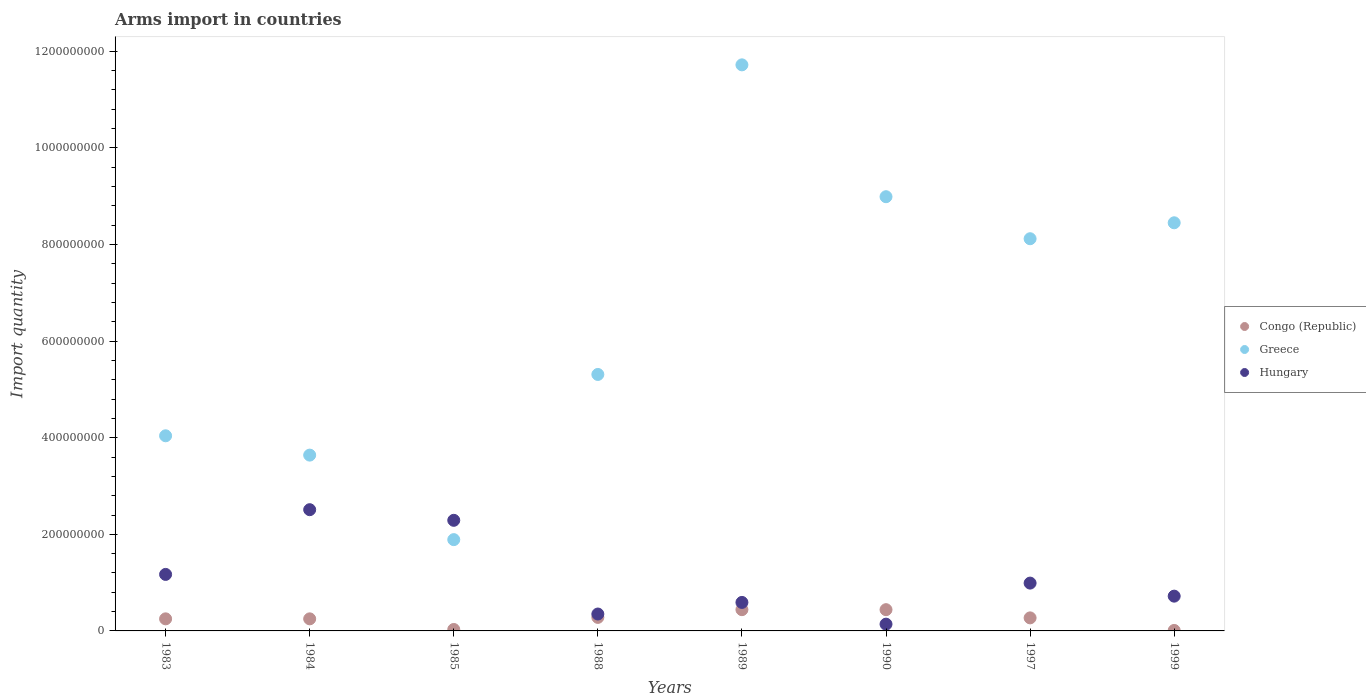Is the number of dotlines equal to the number of legend labels?
Offer a terse response. Yes. What is the total arms import in Greece in 1988?
Your response must be concise. 5.31e+08. Across all years, what is the maximum total arms import in Hungary?
Make the answer very short. 2.51e+08. Across all years, what is the minimum total arms import in Greece?
Your response must be concise. 1.89e+08. In which year was the total arms import in Hungary maximum?
Give a very brief answer. 1984. What is the total total arms import in Greece in the graph?
Your response must be concise. 5.22e+09. What is the difference between the total arms import in Congo (Republic) in 1990 and that in 1997?
Your answer should be very brief. 1.70e+07. What is the difference between the total arms import in Hungary in 1985 and the total arms import in Greece in 1989?
Make the answer very short. -9.43e+08. What is the average total arms import in Hungary per year?
Your answer should be compact. 1.10e+08. In the year 1984, what is the difference between the total arms import in Congo (Republic) and total arms import in Hungary?
Provide a short and direct response. -2.26e+08. In how many years, is the total arms import in Hungary greater than 80000000?
Give a very brief answer. 4. What is the ratio of the total arms import in Hungary in 1984 to that in 1997?
Provide a succinct answer. 2.54. Is the difference between the total arms import in Congo (Republic) in 1984 and 1999 greater than the difference between the total arms import in Hungary in 1984 and 1999?
Your answer should be compact. No. What is the difference between the highest and the lowest total arms import in Greece?
Provide a short and direct response. 9.83e+08. In how many years, is the total arms import in Congo (Republic) greater than the average total arms import in Congo (Republic) taken over all years?
Offer a very short reply. 6. Is the total arms import in Hungary strictly greater than the total arms import in Greece over the years?
Keep it short and to the point. No. Are the values on the major ticks of Y-axis written in scientific E-notation?
Your answer should be compact. No. Does the graph contain any zero values?
Keep it short and to the point. No. Does the graph contain grids?
Provide a succinct answer. No. How many legend labels are there?
Make the answer very short. 3. How are the legend labels stacked?
Make the answer very short. Vertical. What is the title of the graph?
Offer a very short reply. Arms import in countries. Does "Togo" appear as one of the legend labels in the graph?
Provide a succinct answer. No. What is the label or title of the X-axis?
Give a very brief answer. Years. What is the label or title of the Y-axis?
Provide a succinct answer. Import quantity. What is the Import quantity of Congo (Republic) in 1983?
Make the answer very short. 2.50e+07. What is the Import quantity in Greece in 1983?
Provide a succinct answer. 4.04e+08. What is the Import quantity of Hungary in 1983?
Give a very brief answer. 1.17e+08. What is the Import quantity of Congo (Republic) in 1984?
Keep it short and to the point. 2.50e+07. What is the Import quantity in Greece in 1984?
Provide a short and direct response. 3.64e+08. What is the Import quantity in Hungary in 1984?
Your answer should be very brief. 2.51e+08. What is the Import quantity in Congo (Republic) in 1985?
Provide a short and direct response. 3.00e+06. What is the Import quantity of Greece in 1985?
Offer a terse response. 1.89e+08. What is the Import quantity of Hungary in 1985?
Offer a terse response. 2.29e+08. What is the Import quantity in Congo (Republic) in 1988?
Make the answer very short. 2.80e+07. What is the Import quantity of Greece in 1988?
Make the answer very short. 5.31e+08. What is the Import quantity in Hungary in 1988?
Your answer should be very brief. 3.50e+07. What is the Import quantity of Congo (Republic) in 1989?
Provide a succinct answer. 4.40e+07. What is the Import quantity of Greece in 1989?
Your answer should be very brief. 1.17e+09. What is the Import quantity of Hungary in 1989?
Your answer should be very brief. 5.90e+07. What is the Import quantity of Congo (Republic) in 1990?
Offer a terse response. 4.40e+07. What is the Import quantity of Greece in 1990?
Offer a terse response. 8.99e+08. What is the Import quantity in Hungary in 1990?
Make the answer very short. 1.40e+07. What is the Import quantity in Congo (Republic) in 1997?
Keep it short and to the point. 2.70e+07. What is the Import quantity of Greece in 1997?
Your answer should be compact. 8.12e+08. What is the Import quantity in Hungary in 1997?
Keep it short and to the point. 9.90e+07. What is the Import quantity in Greece in 1999?
Provide a succinct answer. 8.45e+08. What is the Import quantity in Hungary in 1999?
Offer a terse response. 7.20e+07. Across all years, what is the maximum Import quantity of Congo (Republic)?
Offer a very short reply. 4.40e+07. Across all years, what is the maximum Import quantity in Greece?
Ensure brevity in your answer.  1.17e+09. Across all years, what is the maximum Import quantity of Hungary?
Ensure brevity in your answer.  2.51e+08. Across all years, what is the minimum Import quantity in Congo (Republic)?
Ensure brevity in your answer.  1.00e+06. Across all years, what is the minimum Import quantity of Greece?
Offer a terse response. 1.89e+08. Across all years, what is the minimum Import quantity in Hungary?
Provide a short and direct response. 1.40e+07. What is the total Import quantity in Congo (Republic) in the graph?
Offer a terse response. 1.97e+08. What is the total Import quantity of Greece in the graph?
Offer a very short reply. 5.22e+09. What is the total Import quantity of Hungary in the graph?
Ensure brevity in your answer.  8.76e+08. What is the difference between the Import quantity of Congo (Republic) in 1983 and that in 1984?
Offer a terse response. 0. What is the difference between the Import quantity of Greece in 1983 and that in 1984?
Give a very brief answer. 4.00e+07. What is the difference between the Import quantity of Hungary in 1983 and that in 1984?
Provide a short and direct response. -1.34e+08. What is the difference between the Import quantity of Congo (Republic) in 1983 and that in 1985?
Offer a very short reply. 2.20e+07. What is the difference between the Import quantity of Greece in 1983 and that in 1985?
Offer a very short reply. 2.15e+08. What is the difference between the Import quantity of Hungary in 1983 and that in 1985?
Give a very brief answer. -1.12e+08. What is the difference between the Import quantity in Greece in 1983 and that in 1988?
Your response must be concise. -1.27e+08. What is the difference between the Import quantity of Hungary in 1983 and that in 1988?
Give a very brief answer. 8.20e+07. What is the difference between the Import quantity of Congo (Republic) in 1983 and that in 1989?
Offer a terse response. -1.90e+07. What is the difference between the Import quantity of Greece in 1983 and that in 1989?
Provide a short and direct response. -7.68e+08. What is the difference between the Import quantity in Hungary in 1983 and that in 1989?
Offer a very short reply. 5.80e+07. What is the difference between the Import quantity of Congo (Republic) in 1983 and that in 1990?
Give a very brief answer. -1.90e+07. What is the difference between the Import quantity of Greece in 1983 and that in 1990?
Provide a short and direct response. -4.95e+08. What is the difference between the Import quantity of Hungary in 1983 and that in 1990?
Make the answer very short. 1.03e+08. What is the difference between the Import quantity of Greece in 1983 and that in 1997?
Offer a terse response. -4.08e+08. What is the difference between the Import quantity of Hungary in 1983 and that in 1997?
Your response must be concise. 1.80e+07. What is the difference between the Import quantity in Congo (Republic) in 1983 and that in 1999?
Offer a very short reply. 2.40e+07. What is the difference between the Import quantity in Greece in 1983 and that in 1999?
Make the answer very short. -4.41e+08. What is the difference between the Import quantity of Hungary in 1983 and that in 1999?
Provide a succinct answer. 4.50e+07. What is the difference between the Import quantity of Congo (Republic) in 1984 and that in 1985?
Your answer should be very brief. 2.20e+07. What is the difference between the Import quantity in Greece in 1984 and that in 1985?
Your response must be concise. 1.75e+08. What is the difference between the Import quantity in Hungary in 1984 and that in 1985?
Offer a very short reply. 2.20e+07. What is the difference between the Import quantity in Congo (Republic) in 1984 and that in 1988?
Keep it short and to the point. -3.00e+06. What is the difference between the Import quantity in Greece in 1984 and that in 1988?
Make the answer very short. -1.67e+08. What is the difference between the Import quantity in Hungary in 1984 and that in 1988?
Offer a very short reply. 2.16e+08. What is the difference between the Import quantity in Congo (Republic) in 1984 and that in 1989?
Offer a very short reply. -1.90e+07. What is the difference between the Import quantity in Greece in 1984 and that in 1989?
Make the answer very short. -8.08e+08. What is the difference between the Import quantity in Hungary in 1984 and that in 1989?
Your answer should be very brief. 1.92e+08. What is the difference between the Import quantity of Congo (Republic) in 1984 and that in 1990?
Offer a terse response. -1.90e+07. What is the difference between the Import quantity in Greece in 1984 and that in 1990?
Provide a succinct answer. -5.35e+08. What is the difference between the Import quantity in Hungary in 1984 and that in 1990?
Your response must be concise. 2.37e+08. What is the difference between the Import quantity in Congo (Republic) in 1984 and that in 1997?
Your answer should be compact. -2.00e+06. What is the difference between the Import quantity of Greece in 1984 and that in 1997?
Make the answer very short. -4.48e+08. What is the difference between the Import quantity of Hungary in 1984 and that in 1997?
Your response must be concise. 1.52e+08. What is the difference between the Import quantity of Congo (Republic) in 1984 and that in 1999?
Provide a short and direct response. 2.40e+07. What is the difference between the Import quantity in Greece in 1984 and that in 1999?
Ensure brevity in your answer.  -4.81e+08. What is the difference between the Import quantity of Hungary in 1984 and that in 1999?
Offer a very short reply. 1.79e+08. What is the difference between the Import quantity in Congo (Republic) in 1985 and that in 1988?
Your response must be concise. -2.50e+07. What is the difference between the Import quantity in Greece in 1985 and that in 1988?
Offer a very short reply. -3.42e+08. What is the difference between the Import quantity of Hungary in 1985 and that in 1988?
Ensure brevity in your answer.  1.94e+08. What is the difference between the Import quantity in Congo (Republic) in 1985 and that in 1989?
Your answer should be very brief. -4.10e+07. What is the difference between the Import quantity of Greece in 1985 and that in 1989?
Provide a succinct answer. -9.83e+08. What is the difference between the Import quantity in Hungary in 1985 and that in 1989?
Offer a terse response. 1.70e+08. What is the difference between the Import quantity of Congo (Republic) in 1985 and that in 1990?
Give a very brief answer. -4.10e+07. What is the difference between the Import quantity in Greece in 1985 and that in 1990?
Keep it short and to the point. -7.10e+08. What is the difference between the Import quantity of Hungary in 1985 and that in 1990?
Provide a succinct answer. 2.15e+08. What is the difference between the Import quantity of Congo (Republic) in 1985 and that in 1997?
Your answer should be compact. -2.40e+07. What is the difference between the Import quantity of Greece in 1985 and that in 1997?
Provide a succinct answer. -6.23e+08. What is the difference between the Import quantity in Hungary in 1985 and that in 1997?
Keep it short and to the point. 1.30e+08. What is the difference between the Import quantity of Greece in 1985 and that in 1999?
Ensure brevity in your answer.  -6.56e+08. What is the difference between the Import quantity in Hungary in 1985 and that in 1999?
Your answer should be compact. 1.57e+08. What is the difference between the Import quantity in Congo (Republic) in 1988 and that in 1989?
Your answer should be compact. -1.60e+07. What is the difference between the Import quantity in Greece in 1988 and that in 1989?
Keep it short and to the point. -6.41e+08. What is the difference between the Import quantity of Hungary in 1988 and that in 1989?
Make the answer very short. -2.40e+07. What is the difference between the Import quantity in Congo (Republic) in 1988 and that in 1990?
Your answer should be very brief. -1.60e+07. What is the difference between the Import quantity of Greece in 1988 and that in 1990?
Offer a terse response. -3.68e+08. What is the difference between the Import quantity in Hungary in 1988 and that in 1990?
Provide a succinct answer. 2.10e+07. What is the difference between the Import quantity in Congo (Republic) in 1988 and that in 1997?
Provide a succinct answer. 1.00e+06. What is the difference between the Import quantity in Greece in 1988 and that in 1997?
Provide a short and direct response. -2.81e+08. What is the difference between the Import quantity of Hungary in 1988 and that in 1997?
Your response must be concise. -6.40e+07. What is the difference between the Import quantity in Congo (Republic) in 1988 and that in 1999?
Provide a short and direct response. 2.70e+07. What is the difference between the Import quantity in Greece in 1988 and that in 1999?
Give a very brief answer. -3.14e+08. What is the difference between the Import quantity in Hungary in 1988 and that in 1999?
Your response must be concise. -3.70e+07. What is the difference between the Import quantity in Greece in 1989 and that in 1990?
Your response must be concise. 2.73e+08. What is the difference between the Import quantity of Hungary in 1989 and that in 1990?
Offer a terse response. 4.50e+07. What is the difference between the Import quantity in Congo (Republic) in 1989 and that in 1997?
Your answer should be very brief. 1.70e+07. What is the difference between the Import quantity of Greece in 1989 and that in 1997?
Make the answer very short. 3.60e+08. What is the difference between the Import quantity of Hungary in 1989 and that in 1997?
Your answer should be compact. -4.00e+07. What is the difference between the Import quantity in Congo (Republic) in 1989 and that in 1999?
Your response must be concise. 4.30e+07. What is the difference between the Import quantity of Greece in 1989 and that in 1999?
Keep it short and to the point. 3.27e+08. What is the difference between the Import quantity of Hungary in 1989 and that in 1999?
Provide a short and direct response. -1.30e+07. What is the difference between the Import quantity in Congo (Republic) in 1990 and that in 1997?
Give a very brief answer. 1.70e+07. What is the difference between the Import quantity of Greece in 1990 and that in 1997?
Offer a terse response. 8.70e+07. What is the difference between the Import quantity in Hungary in 1990 and that in 1997?
Your answer should be very brief. -8.50e+07. What is the difference between the Import quantity in Congo (Republic) in 1990 and that in 1999?
Ensure brevity in your answer.  4.30e+07. What is the difference between the Import quantity of Greece in 1990 and that in 1999?
Your answer should be very brief. 5.40e+07. What is the difference between the Import quantity in Hungary in 1990 and that in 1999?
Offer a very short reply. -5.80e+07. What is the difference between the Import quantity in Congo (Republic) in 1997 and that in 1999?
Give a very brief answer. 2.60e+07. What is the difference between the Import quantity of Greece in 1997 and that in 1999?
Give a very brief answer. -3.30e+07. What is the difference between the Import quantity of Hungary in 1997 and that in 1999?
Give a very brief answer. 2.70e+07. What is the difference between the Import quantity of Congo (Republic) in 1983 and the Import quantity of Greece in 1984?
Give a very brief answer. -3.39e+08. What is the difference between the Import quantity in Congo (Republic) in 1983 and the Import quantity in Hungary in 1984?
Provide a short and direct response. -2.26e+08. What is the difference between the Import quantity in Greece in 1983 and the Import quantity in Hungary in 1984?
Your answer should be very brief. 1.53e+08. What is the difference between the Import quantity in Congo (Republic) in 1983 and the Import quantity in Greece in 1985?
Keep it short and to the point. -1.64e+08. What is the difference between the Import quantity in Congo (Republic) in 1983 and the Import quantity in Hungary in 1985?
Offer a very short reply. -2.04e+08. What is the difference between the Import quantity in Greece in 1983 and the Import quantity in Hungary in 1985?
Give a very brief answer. 1.75e+08. What is the difference between the Import quantity in Congo (Republic) in 1983 and the Import quantity in Greece in 1988?
Provide a short and direct response. -5.06e+08. What is the difference between the Import quantity in Congo (Republic) in 1983 and the Import quantity in Hungary in 1988?
Give a very brief answer. -1.00e+07. What is the difference between the Import quantity in Greece in 1983 and the Import quantity in Hungary in 1988?
Provide a succinct answer. 3.69e+08. What is the difference between the Import quantity in Congo (Republic) in 1983 and the Import quantity in Greece in 1989?
Make the answer very short. -1.15e+09. What is the difference between the Import quantity in Congo (Republic) in 1983 and the Import quantity in Hungary in 1989?
Provide a short and direct response. -3.40e+07. What is the difference between the Import quantity in Greece in 1983 and the Import quantity in Hungary in 1989?
Offer a terse response. 3.45e+08. What is the difference between the Import quantity of Congo (Republic) in 1983 and the Import quantity of Greece in 1990?
Make the answer very short. -8.74e+08. What is the difference between the Import quantity of Congo (Republic) in 1983 and the Import quantity of Hungary in 1990?
Ensure brevity in your answer.  1.10e+07. What is the difference between the Import quantity of Greece in 1983 and the Import quantity of Hungary in 1990?
Your answer should be very brief. 3.90e+08. What is the difference between the Import quantity in Congo (Republic) in 1983 and the Import quantity in Greece in 1997?
Offer a very short reply. -7.87e+08. What is the difference between the Import quantity of Congo (Republic) in 1983 and the Import quantity of Hungary in 1997?
Give a very brief answer. -7.40e+07. What is the difference between the Import quantity of Greece in 1983 and the Import quantity of Hungary in 1997?
Make the answer very short. 3.05e+08. What is the difference between the Import quantity in Congo (Republic) in 1983 and the Import quantity in Greece in 1999?
Offer a very short reply. -8.20e+08. What is the difference between the Import quantity of Congo (Republic) in 1983 and the Import quantity of Hungary in 1999?
Give a very brief answer. -4.70e+07. What is the difference between the Import quantity in Greece in 1983 and the Import quantity in Hungary in 1999?
Your answer should be very brief. 3.32e+08. What is the difference between the Import quantity of Congo (Republic) in 1984 and the Import quantity of Greece in 1985?
Give a very brief answer. -1.64e+08. What is the difference between the Import quantity of Congo (Republic) in 1984 and the Import quantity of Hungary in 1985?
Offer a terse response. -2.04e+08. What is the difference between the Import quantity in Greece in 1984 and the Import quantity in Hungary in 1985?
Your response must be concise. 1.35e+08. What is the difference between the Import quantity in Congo (Republic) in 1984 and the Import quantity in Greece in 1988?
Keep it short and to the point. -5.06e+08. What is the difference between the Import quantity of Congo (Republic) in 1984 and the Import quantity of Hungary in 1988?
Make the answer very short. -1.00e+07. What is the difference between the Import quantity in Greece in 1984 and the Import quantity in Hungary in 1988?
Offer a terse response. 3.29e+08. What is the difference between the Import quantity of Congo (Republic) in 1984 and the Import quantity of Greece in 1989?
Ensure brevity in your answer.  -1.15e+09. What is the difference between the Import quantity of Congo (Republic) in 1984 and the Import quantity of Hungary in 1989?
Offer a terse response. -3.40e+07. What is the difference between the Import quantity of Greece in 1984 and the Import quantity of Hungary in 1989?
Give a very brief answer. 3.05e+08. What is the difference between the Import quantity of Congo (Republic) in 1984 and the Import quantity of Greece in 1990?
Your answer should be compact. -8.74e+08. What is the difference between the Import quantity in Congo (Republic) in 1984 and the Import quantity in Hungary in 1990?
Provide a succinct answer. 1.10e+07. What is the difference between the Import quantity of Greece in 1984 and the Import quantity of Hungary in 1990?
Give a very brief answer. 3.50e+08. What is the difference between the Import quantity in Congo (Republic) in 1984 and the Import quantity in Greece in 1997?
Provide a short and direct response. -7.87e+08. What is the difference between the Import quantity in Congo (Republic) in 1984 and the Import quantity in Hungary in 1997?
Your answer should be very brief. -7.40e+07. What is the difference between the Import quantity in Greece in 1984 and the Import quantity in Hungary in 1997?
Offer a very short reply. 2.65e+08. What is the difference between the Import quantity in Congo (Republic) in 1984 and the Import quantity in Greece in 1999?
Ensure brevity in your answer.  -8.20e+08. What is the difference between the Import quantity of Congo (Republic) in 1984 and the Import quantity of Hungary in 1999?
Make the answer very short. -4.70e+07. What is the difference between the Import quantity of Greece in 1984 and the Import quantity of Hungary in 1999?
Provide a short and direct response. 2.92e+08. What is the difference between the Import quantity of Congo (Republic) in 1985 and the Import quantity of Greece in 1988?
Your answer should be compact. -5.28e+08. What is the difference between the Import quantity of Congo (Republic) in 1985 and the Import quantity of Hungary in 1988?
Your answer should be compact. -3.20e+07. What is the difference between the Import quantity in Greece in 1985 and the Import quantity in Hungary in 1988?
Ensure brevity in your answer.  1.54e+08. What is the difference between the Import quantity of Congo (Republic) in 1985 and the Import quantity of Greece in 1989?
Keep it short and to the point. -1.17e+09. What is the difference between the Import quantity of Congo (Republic) in 1985 and the Import quantity of Hungary in 1989?
Ensure brevity in your answer.  -5.60e+07. What is the difference between the Import quantity of Greece in 1985 and the Import quantity of Hungary in 1989?
Make the answer very short. 1.30e+08. What is the difference between the Import quantity of Congo (Republic) in 1985 and the Import quantity of Greece in 1990?
Your answer should be very brief. -8.96e+08. What is the difference between the Import quantity of Congo (Republic) in 1985 and the Import quantity of Hungary in 1990?
Provide a short and direct response. -1.10e+07. What is the difference between the Import quantity in Greece in 1985 and the Import quantity in Hungary in 1990?
Your answer should be compact. 1.75e+08. What is the difference between the Import quantity in Congo (Republic) in 1985 and the Import quantity in Greece in 1997?
Offer a terse response. -8.09e+08. What is the difference between the Import quantity of Congo (Republic) in 1985 and the Import quantity of Hungary in 1997?
Your response must be concise. -9.60e+07. What is the difference between the Import quantity of Greece in 1985 and the Import quantity of Hungary in 1997?
Make the answer very short. 9.00e+07. What is the difference between the Import quantity in Congo (Republic) in 1985 and the Import quantity in Greece in 1999?
Make the answer very short. -8.42e+08. What is the difference between the Import quantity in Congo (Republic) in 1985 and the Import quantity in Hungary in 1999?
Provide a succinct answer. -6.90e+07. What is the difference between the Import quantity of Greece in 1985 and the Import quantity of Hungary in 1999?
Make the answer very short. 1.17e+08. What is the difference between the Import quantity of Congo (Republic) in 1988 and the Import quantity of Greece in 1989?
Your answer should be very brief. -1.14e+09. What is the difference between the Import quantity in Congo (Republic) in 1988 and the Import quantity in Hungary in 1989?
Ensure brevity in your answer.  -3.10e+07. What is the difference between the Import quantity in Greece in 1988 and the Import quantity in Hungary in 1989?
Give a very brief answer. 4.72e+08. What is the difference between the Import quantity in Congo (Republic) in 1988 and the Import quantity in Greece in 1990?
Provide a short and direct response. -8.71e+08. What is the difference between the Import quantity of Congo (Republic) in 1988 and the Import quantity of Hungary in 1990?
Your response must be concise. 1.40e+07. What is the difference between the Import quantity of Greece in 1988 and the Import quantity of Hungary in 1990?
Your answer should be very brief. 5.17e+08. What is the difference between the Import quantity of Congo (Republic) in 1988 and the Import quantity of Greece in 1997?
Your answer should be very brief. -7.84e+08. What is the difference between the Import quantity of Congo (Republic) in 1988 and the Import quantity of Hungary in 1997?
Make the answer very short. -7.10e+07. What is the difference between the Import quantity in Greece in 1988 and the Import quantity in Hungary in 1997?
Offer a terse response. 4.32e+08. What is the difference between the Import quantity of Congo (Republic) in 1988 and the Import quantity of Greece in 1999?
Your response must be concise. -8.17e+08. What is the difference between the Import quantity in Congo (Republic) in 1988 and the Import quantity in Hungary in 1999?
Your answer should be very brief. -4.40e+07. What is the difference between the Import quantity in Greece in 1988 and the Import quantity in Hungary in 1999?
Provide a short and direct response. 4.59e+08. What is the difference between the Import quantity in Congo (Republic) in 1989 and the Import quantity in Greece in 1990?
Provide a succinct answer. -8.55e+08. What is the difference between the Import quantity in Congo (Republic) in 1989 and the Import quantity in Hungary in 1990?
Your response must be concise. 3.00e+07. What is the difference between the Import quantity of Greece in 1989 and the Import quantity of Hungary in 1990?
Offer a very short reply. 1.16e+09. What is the difference between the Import quantity of Congo (Republic) in 1989 and the Import quantity of Greece in 1997?
Provide a succinct answer. -7.68e+08. What is the difference between the Import quantity of Congo (Republic) in 1989 and the Import quantity of Hungary in 1997?
Keep it short and to the point. -5.50e+07. What is the difference between the Import quantity in Greece in 1989 and the Import quantity in Hungary in 1997?
Ensure brevity in your answer.  1.07e+09. What is the difference between the Import quantity of Congo (Republic) in 1989 and the Import quantity of Greece in 1999?
Keep it short and to the point. -8.01e+08. What is the difference between the Import quantity of Congo (Republic) in 1989 and the Import quantity of Hungary in 1999?
Your answer should be very brief. -2.80e+07. What is the difference between the Import quantity in Greece in 1989 and the Import quantity in Hungary in 1999?
Your response must be concise. 1.10e+09. What is the difference between the Import quantity in Congo (Republic) in 1990 and the Import quantity in Greece in 1997?
Your response must be concise. -7.68e+08. What is the difference between the Import quantity of Congo (Republic) in 1990 and the Import quantity of Hungary in 1997?
Ensure brevity in your answer.  -5.50e+07. What is the difference between the Import quantity in Greece in 1990 and the Import quantity in Hungary in 1997?
Offer a very short reply. 8.00e+08. What is the difference between the Import quantity of Congo (Republic) in 1990 and the Import quantity of Greece in 1999?
Provide a short and direct response. -8.01e+08. What is the difference between the Import quantity of Congo (Republic) in 1990 and the Import quantity of Hungary in 1999?
Offer a very short reply. -2.80e+07. What is the difference between the Import quantity of Greece in 1990 and the Import quantity of Hungary in 1999?
Give a very brief answer. 8.27e+08. What is the difference between the Import quantity of Congo (Republic) in 1997 and the Import quantity of Greece in 1999?
Your response must be concise. -8.18e+08. What is the difference between the Import quantity of Congo (Republic) in 1997 and the Import quantity of Hungary in 1999?
Provide a succinct answer. -4.50e+07. What is the difference between the Import quantity of Greece in 1997 and the Import quantity of Hungary in 1999?
Provide a short and direct response. 7.40e+08. What is the average Import quantity of Congo (Republic) per year?
Your answer should be very brief. 2.46e+07. What is the average Import quantity in Greece per year?
Provide a short and direct response. 6.52e+08. What is the average Import quantity in Hungary per year?
Give a very brief answer. 1.10e+08. In the year 1983, what is the difference between the Import quantity in Congo (Republic) and Import quantity in Greece?
Provide a succinct answer. -3.79e+08. In the year 1983, what is the difference between the Import quantity of Congo (Republic) and Import quantity of Hungary?
Give a very brief answer. -9.20e+07. In the year 1983, what is the difference between the Import quantity in Greece and Import quantity in Hungary?
Provide a succinct answer. 2.87e+08. In the year 1984, what is the difference between the Import quantity in Congo (Republic) and Import quantity in Greece?
Offer a terse response. -3.39e+08. In the year 1984, what is the difference between the Import quantity in Congo (Republic) and Import quantity in Hungary?
Your answer should be very brief. -2.26e+08. In the year 1984, what is the difference between the Import quantity of Greece and Import quantity of Hungary?
Offer a terse response. 1.13e+08. In the year 1985, what is the difference between the Import quantity of Congo (Republic) and Import quantity of Greece?
Keep it short and to the point. -1.86e+08. In the year 1985, what is the difference between the Import quantity in Congo (Republic) and Import quantity in Hungary?
Offer a terse response. -2.26e+08. In the year 1985, what is the difference between the Import quantity of Greece and Import quantity of Hungary?
Offer a terse response. -4.00e+07. In the year 1988, what is the difference between the Import quantity of Congo (Republic) and Import quantity of Greece?
Offer a terse response. -5.03e+08. In the year 1988, what is the difference between the Import quantity in Congo (Republic) and Import quantity in Hungary?
Provide a short and direct response. -7.00e+06. In the year 1988, what is the difference between the Import quantity in Greece and Import quantity in Hungary?
Your answer should be very brief. 4.96e+08. In the year 1989, what is the difference between the Import quantity of Congo (Republic) and Import quantity of Greece?
Your answer should be compact. -1.13e+09. In the year 1989, what is the difference between the Import quantity in Congo (Republic) and Import quantity in Hungary?
Make the answer very short. -1.50e+07. In the year 1989, what is the difference between the Import quantity of Greece and Import quantity of Hungary?
Your answer should be compact. 1.11e+09. In the year 1990, what is the difference between the Import quantity of Congo (Republic) and Import quantity of Greece?
Keep it short and to the point. -8.55e+08. In the year 1990, what is the difference between the Import quantity of Congo (Republic) and Import quantity of Hungary?
Your response must be concise. 3.00e+07. In the year 1990, what is the difference between the Import quantity in Greece and Import quantity in Hungary?
Offer a terse response. 8.85e+08. In the year 1997, what is the difference between the Import quantity in Congo (Republic) and Import quantity in Greece?
Provide a succinct answer. -7.85e+08. In the year 1997, what is the difference between the Import quantity of Congo (Republic) and Import quantity of Hungary?
Your answer should be very brief. -7.20e+07. In the year 1997, what is the difference between the Import quantity in Greece and Import quantity in Hungary?
Give a very brief answer. 7.13e+08. In the year 1999, what is the difference between the Import quantity of Congo (Republic) and Import quantity of Greece?
Ensure brevity in your answer.  -8.44e+08. In the year 1999, what is the difference between the Import quantity in Congo (Republic) and Import quantity in Hungary?
Offer a very short reply. -7.10e+07. In the year 1999, what is the difference between the Import quantity in Greece and Import quantity in Hungary?
Provide a short and direct response. 7.73e+08. What is the ratio of the Import quantity in Congo (Republic) in 1983 to that in 1984?
Make the answer very short. 1. What is the ratio of the Import quantity in Greece in 1983 to that in 1984?
Your answer should be very brief. 1.11. What is the ratio of the Import quantity in Hungary in 1983 to that in 1984?
Provide a succinct answer. 0.47. What is the ratio of the Import quantity of Congo (Republic) in 1983 to that in 1985?
Give a very brief answer. 8.33. What is the ratio of the Import quantity in Greece in 1983 to that in 1985?
Give a very brief answer. 2.14. What is the ratio of the Import quantity in Hungary in 1983 to that in 1985?
Your answer should be very brief. 0.51. What is the ratio of the Import quantity of Congo (Republic) in 1983 to that in 1988?
Your answer should be very brief. 0.89. What is the ratio of the Import quantity of Greece in 1983 to that in 1988?
Give a very brief answer. 0.76. What is the ratio of the Import quantity in Hungary in 1983 to that in 1988?
Offer a very short reply. 3.34. What is the ratio of the Import quantity of Congo (Republic) in 1983 to that in 1989?
Offer a very short reply. 0.57. What is the ratio of the Import quantity in Greece in 1983 to that in 1989?
Make the answer very short. 0.34. What is the ratio of the Import quantity in Hungary in 1983 to that in 1989?
Your response must be concise. 1.98. What is the ratio of the Import quantity of Congo (Republic) in 1983 to that in 1990?
Make the answer very short. 0.57. What is the ratio of the Import quantity of Greece in 1983 to that in 1990?
Provide a short and direct response. 0.45. What is the ratio of the Import quantity in Hungary in 1983 to that in 1990?
Provide a short and direct response. 8.36. What is the ratio of the Import quantity of Congo (Republic) in 1983 to that in 1997?
Your answer should be compact. 0.93. What is the ratio of the Import quantity of Greece in 1983 to that in 1997?
Ensure brevity in your answer.  0.5. What is the ratio of the Import quantity of Hungary in 1983 to that in 1997?
Offer a very short reply. 1.18. What is the ratio of the Import quantity of Greece in 1983 to that in 1999?
Keep it short and to the point. 0.48. What is the ratio of the Import quantity of Hungary in 1983 to that in 1999?
Give a very brief answer. 1.62. What is the ratio of the Import quantity in Congo (Republic) in 1984 to that in 1985?
Your answer should be compact. 8.33. What is the ratio of the Import quantity in Greece in 1984 to that in 1985?
Keep it short and to the point. 1.93. What is the ratio of the Import quantity of Hungary in 1984 to that in 1985?
Give a very brief answer. 1.1. What is the ratio of the Import quantity of Congo (Republic) in 1984 to that in 1988?
Provide a short and direct response. 0.89. What is the ratio of the Import quantity of Greece in 1984 to that in 1988?
Your answer should be compact. 0.69. What is the ratio of the Import quantity in Hungary in 1984 to that in 1988?
Your answer should be compact. 7.17. What is the ratio of the Import quantity in Congo (Republic) in 1984 to that in 1989?
Your response must be concise. 0.57. What is the ratio of the Import quantity in Greece in 1984 to that in 1989?
Provide a short and direct response. 0.31. What is the ratio of the Import quantity in Hungary in 1984 to that in 1989?
Your answer should be compact. 4.25. What is the ratio of the Import quantity in Congo (Republic) in 1984 to that in 1990?
Make the answer very short. 0.57. What is the ratio of the Import quantity of Greece in 1984 to that in 1990?
Offer a very short reply. 0.4. What is the ratio of the Import quantity of Hungary in 1984 to that in 1990?
Ensure brevity in your answer.  17.93. What is the ratio of the Import quantity of Congo (Republic) in 1984 to that in 1997?
Keep it short and to the point. 0.93. What is the ratio of the Import quantity in Greece in 1984 to that in 1997?
Provide a short and direct response. 0.45. What is the ratio of the Import quantity in Hungary in 1984 to that in 1997?
Your answer should be very brief. 2.54. What is the ratio of the Import quantity in Greece in 1984 to that in 1999?
Provide a succinct answer. 0.43. What is the ratio of the Import quantity in Hungary in 1984 to that in 1999?
Your answer should be compact. 3.49. What is the ratio of the Import quantity of Congo (Republic) in 1985 to that in 1988?
Keep it short and to the point. 0.11. What is the ratio of the Import quantity of Greece in 1985 to that in 1988?
Provide a succinct answer. 0.36. What is the ratio of the Import quantity in Hungary in 1985 to that in 1988?
Your response must be concise. 6.54. What is the ratio of the Import quantity of Congo (Republic) in 1985 to that in 1989?
Offer a terse response. 0.07. What is the ratio of the Import quantity in Greece in 1985 to that in 1989?
Offer a very short reply. 0.16. What is the ratio of the Import quantity of Hungary in 1985 to that in 1989?
Your answer should be very brief. 3.88. What is the ratio of the Import quantity of Congo (Republic) in 1985 to that in 1990?
Offer a terse response. 0.07. What is the ratio of the Import quantity in Greece in 1985 to that in 1990?
Provide a succinct answer. 0.21. What is the ratio of the Import quantity of Hungary in 1985 to that in 1990?
Your answer should be compact. 16.36. What is the ratio of the Import quantity in Congo (Republic) in 1985 to that in 1997?
Your answer should be compact. 0.11. What is the ratio of the Import quantity in Greece in 1985 to that in 1997?
Your answer should be very brief. 0.23. What is the ratio of the Import quantity of Hungary in 1985 to that in 1997?
Offer a very short reply. 2.31. What is the ratio of the Import quantity in Greece in 1985 to that in 1999?
Give a very brief answer. 0.22. What is the ratio of the Import quantity of Hungary in 1985 to that in 1999?
Provide a succinct answer. 3.18. What is the ratio of the Import quantity of Congo (Republic) in 1988 to that in 1989?
Your response must be concise. 0.64. What is the ratio of the Import quantity in Greece in 1988 to that in 1989?
Give a very brief answer. 0.45. What is the ratio of the Import quantity in Hungary in 1988 to that in 1989?
Your answer should be compact. 0.59. What is the ratio of the Import quantity of Congo (Republic) in 1988 to that in 1990?
Offer a very short reply. 0.64. What is the ratio of the Import quantity of Greece in 1988 to that in 1990?
Provide a succinct answer. 0.59. What is the ratio of the Import quantity in Congo (Republic) in 1988 to that in 1997?
Make the answer very short. 1.04. What is the ratio of the Import quantity in Greece in 1988 to that in 1997?
Your answer should be very brief. 0.65. What is the ratio of the Import quantity in Hungary in 1988 to that in 1997?
Ensure brevity in your answer.  0.35. What is the ratio of the Import quantity of Greece in 1988 to that in 1999?
Provide a short and direct response. 0.63. What is the ratio of the Import quantity in Hungary in 1988 to that in 1999?
Your answer should be very brief. 0.49. What is the ratio of the Import quantity of Congo (Republic) in 1989 to that in 1990?
Provide a short and direct response. 1. What is the ratio of the Import quantity in Greece in 1989 to that in 1990?
Ensure brevity in your answer.  1.3. What is the ratio of the Import quantity of Hungary in 1989 to that in 1990?
Offer a terse response. 4.21. What is the ratio of the Import quantity of Congo (Republic) in 1989 to that in 1997?
Your answer should be compact. 1.63. What is the ratio of the Import quantity in Greece in 1989 to that in 1997?
Ensure brevity in your answer.  1.44. What is the ratio of the Import quantity of Hungary in 1989 to that in 1997?
Ensure brevity in your answer.  0.6. What is the ratio of the Import quantity of Congo (Republic) in 1989 to that in 1999?
Make the answer very short. 44. What is the ratio of the Import quantity in Greece in 1989 to that in 1999?
Provide a short and direct response. 1.39. What is the ratio of the Import quantity in Hungary in 1989 to that in 1999?
Give a very brief answer. 0.82. What is the ratio of the Import quantity of Congo (Republic) in 1990 to that in 1997?
Keep it short and to the point. 1.63. What is the ratio of the Import quantity in Greece in 1990 to that in 1997?
Provide a succinct answer. 1.11. What is the ratio of the Import quantity of Hungary in 1990 to that in 1997?
Provide a succinct answer. 0.14. What is the ratio of the Import quantity in Congo (Republic) in 1990 to that in 1999?
Your response must be concise. 44. What is the ratio of the Import quantity in Greece in 1990 to that in 1999?
Offer a very short reply. 1.06. What is the ratio of the Import quantity of Hungary in 1990 to that in 1999?
Provide a short and direct response. 0.19. What is the ratio of the Import quantity in Congo (Republic) in 1997 to that in 1999?
Provide a short and direct response. 27. What is the ratio of the Import quantity in Greece in 1997 to that in 1999?
Your response must be concise. 0.96. What is the ratio of the Import quantity in Hungary in 1997 to that in 1999?
Offer a terse response. 1.38. What is the difference between the highest and the second highest Import quantity in Congo (Republic)?
Provide a short and direct response. 0. What is the difference between the highest and the second highest Import quantity in Greece?
Keep it short and to the point. 2.73e+08. What is the difference between the highest and the second highest Import quantity in Hungary?
Ensure brevity in your answer.  2.20e+07. What is the difference between the highest and the lowest Import quantity in Congo (Republic)?
Your response must be concise. 4.30e+07. What is the difference between the highest and the lowest Import quantity in Greece?
Your answer should be compact. 9.83e+08. What is the difference between the highest and the lowest Import quantity of Hungary?
Your answer should be very brief. 2.37e+08. 